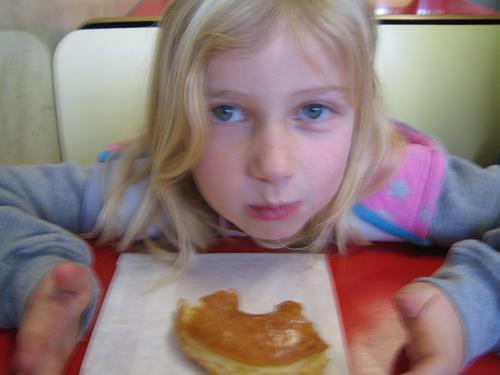Is the frosting likely chocolate?
Concise answer only. No. Is this little girl happy about the donut?
Give a very brief answer. Yes. Is this baby excited?
Answer briefly. No. Does the pastry have sprinkles?
Be succinct. No. Will the girl make a mess?
Keep it brief. No. What color is her hair?
Give a very brief answer. Blonde. Is the child eating from a spoon?
Write a very short answer. No. Is the little girl eating chicken and broccoli?
Concise answer only. No. What is the child eating?
Keep it brief. Donut. Is the girl mad?
Quick response, please. No. Does the little girl have bangs?
Quick response, please. No. What color are this girl's eyes?
Be succinct. Blue. What is this person eating?
Quick response, please. Donut. Is the girl eating pizza with shredded cheese?
Give a very brief answer. No. What does the woman have in her hands?
Short answer required. Nothing. What is on the top of the donut?
Short answer required. Glaze. Is there a drink on the table?
Write a very short answer. No. What food is the child eating?
Give a very brief answer. Doughnut. Does she seem to like what she's eating?
Write a very short answer. No. What is she eating?
Give a very brief answer. Donut. Is the kid happy?
Answer briefly. No. What is the girl eating?
Give a very brief answer. Donut. Is her hair wet?
Answer briefly. No. What is the girl holding?
Answer briefly. Donut. 